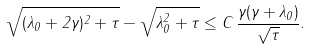Convert formula to latex. <formula><loc_0><loc_0><loc_500><loc_500>\sqrt { ( \lambda _ { 0 } + 2 \gamma ) ^ { 2 } + \tau } - \sqrt { \lambda _ { 0 } ^ { 2 } + \tau } \leq C \, \frac { \gamma ( \gamma + \lambda _ { 0 } ) } { \sqrt { \tau } } .</formula> 